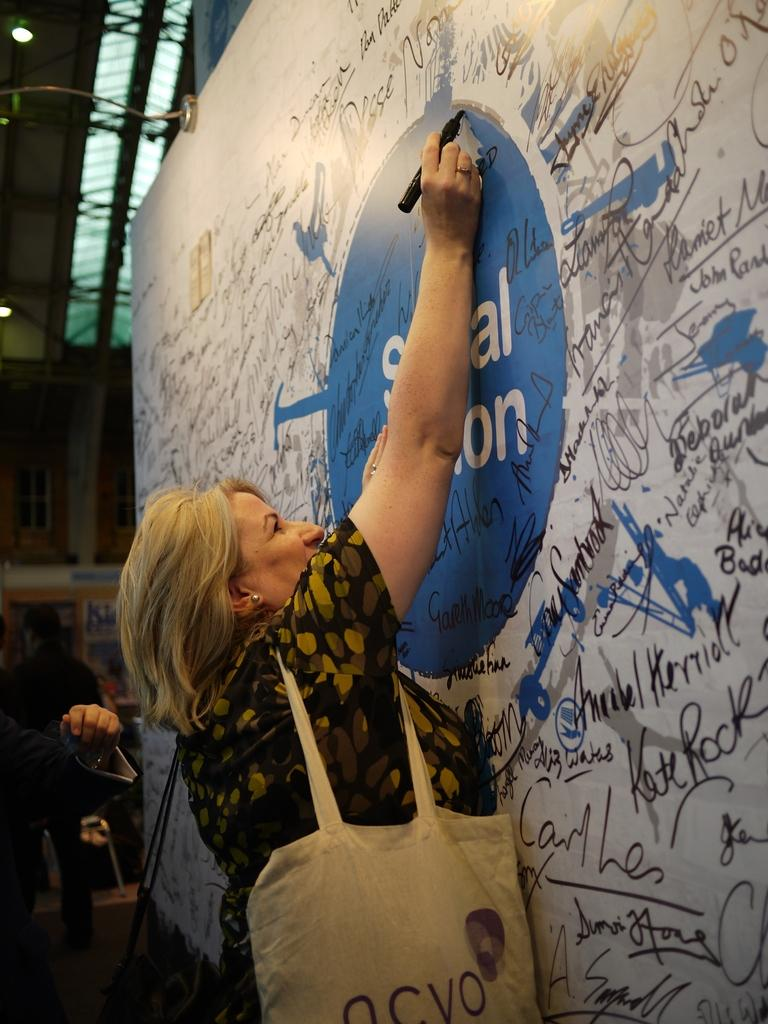Who is the main subject in the image? There is a woman in the image. What is the woman doing in the image? The woman is standing and writing on a board. What can be seen on the board? There is a sketch on the board. What type of ship is the woman driving in the image? There is no ship present in the image, nor is the woman driving anything. 